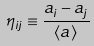Convert formula to latex. <formula><loc_0><loc_0><loc_500><loc_500>\eta _ { i j } \equiv \frac { a _ { i } - a _ { j } } { \langle a \rangle }</formula> 